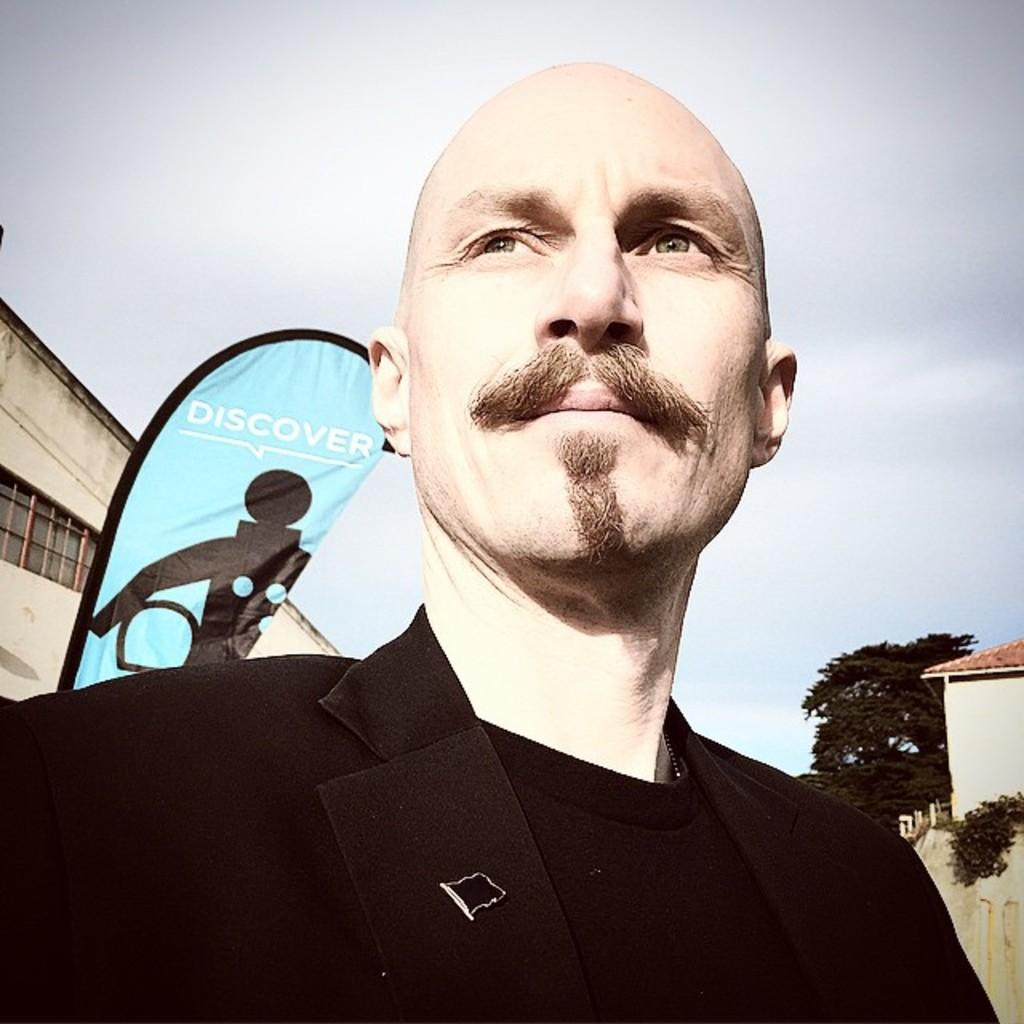Who is present in the image? There is a man in the image. What is the man wearing? The man is wearing a black dress. What can be seen in the background of the image? There is a building in the background of the image. What type of vegetation is on the right side of the image? There is a tree on the right side of the image. What is visible at the top of the image? There are clouds in the sky at the top of the image. How many horses are visible on the roof of the building in the image? There are no horses visible on the roof of the building in the image. What type of adjustment is the man making to the tree in the image? The man is not making any adjustments to the tree in the image; he is simply standing near it. 